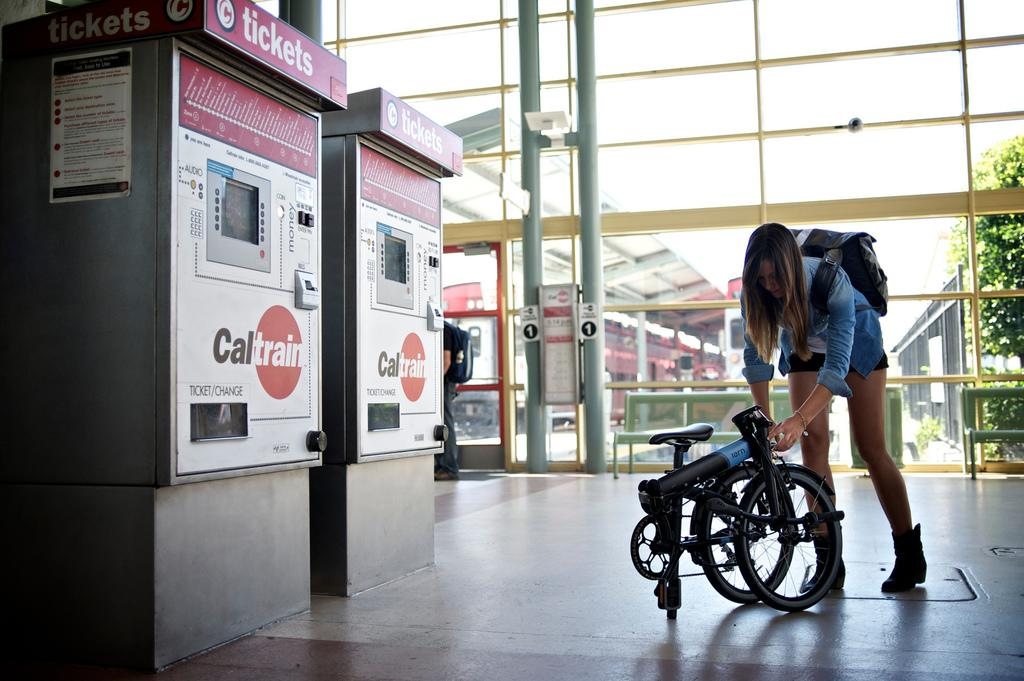Who is present in the image? There is a woman in the image. What object is on the floor in the image? There is a vehicle on the floor in the image. What type of objects can be seen in the image besides the woman and the vehicle? There are boards, boxes, poles, glass, benches, and buildings visible in the image. What part of the natural environment is visible in the image? The sky is visible in the background of the image. How many eyes does the war have in the image? There is no war present in the image, and therefore no eyes can be attributed to it. 